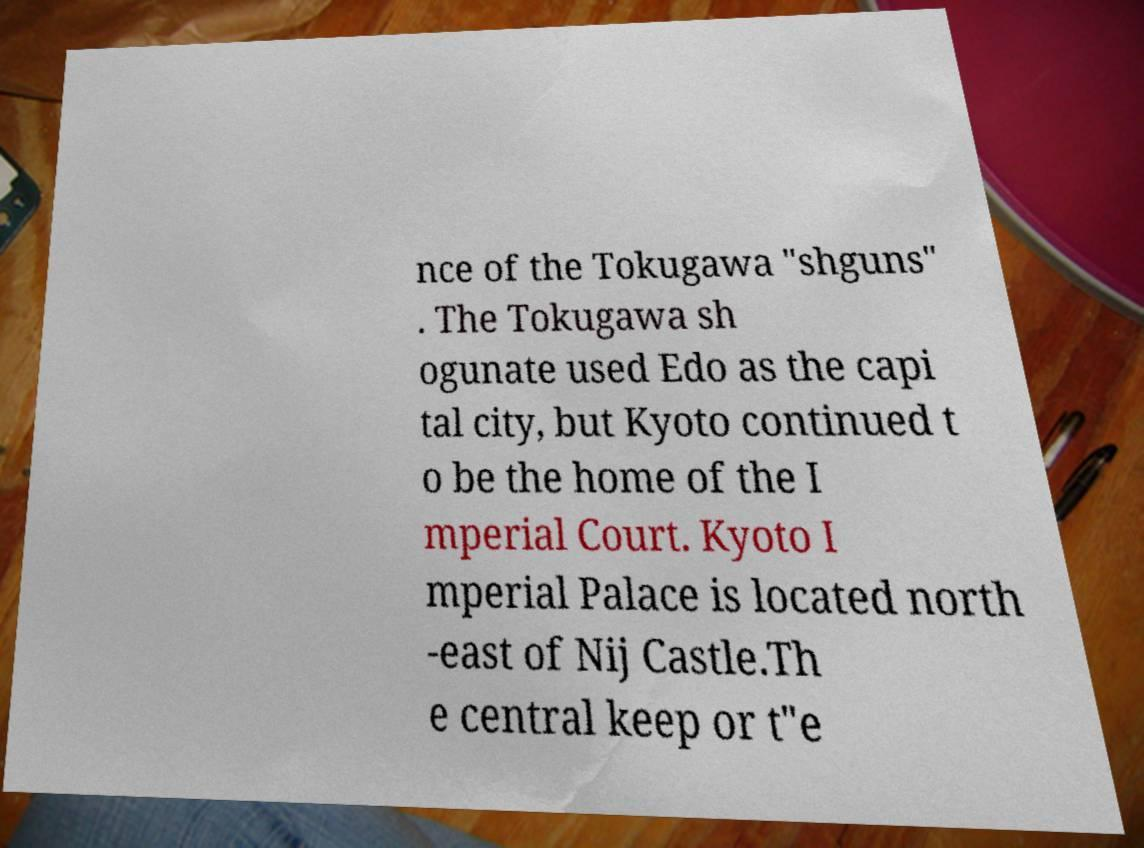There's text embedded in this image that I need extracted. Can you transcribe it verbatim? nce of the Tokugawa "shguns" . The Tokugawa sh ogunate used Edo as the capi tal city, but Kyoto continued t o be the home of the I mperial Court. Kyoto I mperial Palace is located north -east of Nij Castle.Th e central keep or t"e 